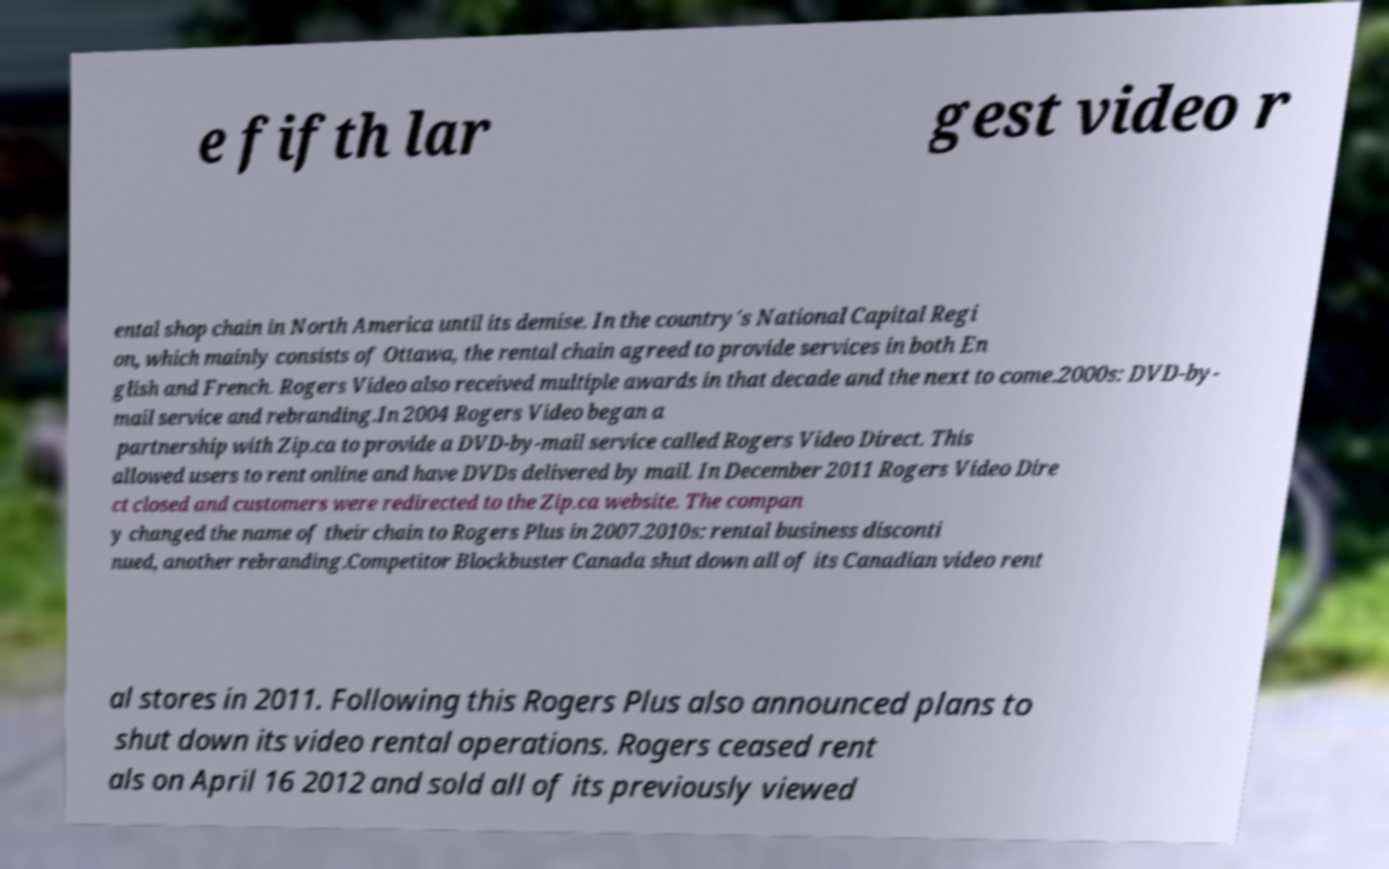Can you accurately transcribe the text from the provided image for me? e fifth lar gest video r ental shop chain in North America until its demise. In the country's National Capital Regi on, which mainly consists of Ottawa, the rental chain agreed to provide services in both En glish and French. Rogers Video also received multiple awards in that decade and the next to come.2000s: DVD-by- mail service and rebranding.In 2004 Rogers Video began a partnership with Zip.ca to provide a DVD-by-mail service called Rogers Video Direct. This allowed users to rent online and have DVDs delivered by mail. In December 2011 Rogers Video Dire ct closed and customers were redirected to the Zip.ca website. The compan y changed the name of their chain to Rogers Plus in 2007.2010s: rental business disconti nued, another rebranding.Competitor Blockbuster Canada shut down all of its Canadian video rent al stores in 2011. Following this Rogers Plus also announced plans to shut down its video rental operations. Rogers ceased rent als on April 16 2012 and sold all of its previously viewed 